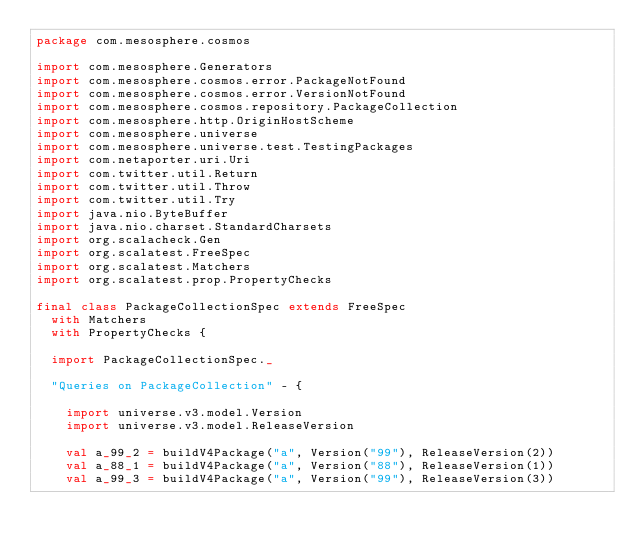Convert code to text. <code><loc_0><loc_0><loc_500><loc_500><_Scala_>package com.mesosphere.cosmos

import com.mesosphere.Generators
import com.mesosphere.cosmos.error.PackageNotFound
import com.mesosphere.cosmos.error.VersionNotFound
import com.mesosphere.cosmos.repository.PackageCollection
import com.mesosphere.http.OriginHostScheme
import com.mesosphere.universe
import com.mesosphere.universe.test.TestingPackages
import com.netaporter.uri.Uri
import com.twitter.util.Return
import com.twitter.util.Throw
import com.twitter.util.Try
import java.nio.ByteBuffer
import java.nio.charset.StandardCharsets
import org.scalacheck.Gen
import org.scalatest.FreeSpec
import org.scalatest.Matchers
import org.scalatest.prop.PropertyChecks

final class PackageCollectionSpec extends FreeSpec
  with Matchers
  with PropertyChecks {

  import PackageCollectionSpec._

  "Queries on PackageCollection" - {

    import universe.v3.model.Version
    import universe.v3.model.ReleaseVersion

    val a_99_2 = buildV4Package("a", Version("99"), ReleaseVersion(2))
    val a_88_1 = buildV4Package("a", Version("88"), ReleaseVersion(1))
    val a_99_3 = buildV4Package("a", Version("99"), ReleaseVersion(3))
</code> 